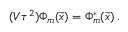<formula> <loc_0><loc_0><loc_500><loc_500>( V \tau ^ { 2 } ) \Phi _ { m } ( { \vec { x } } ) = \Phi _ { m } ^ { \ast } ( { \vec { x } } ) \, .</formula> 